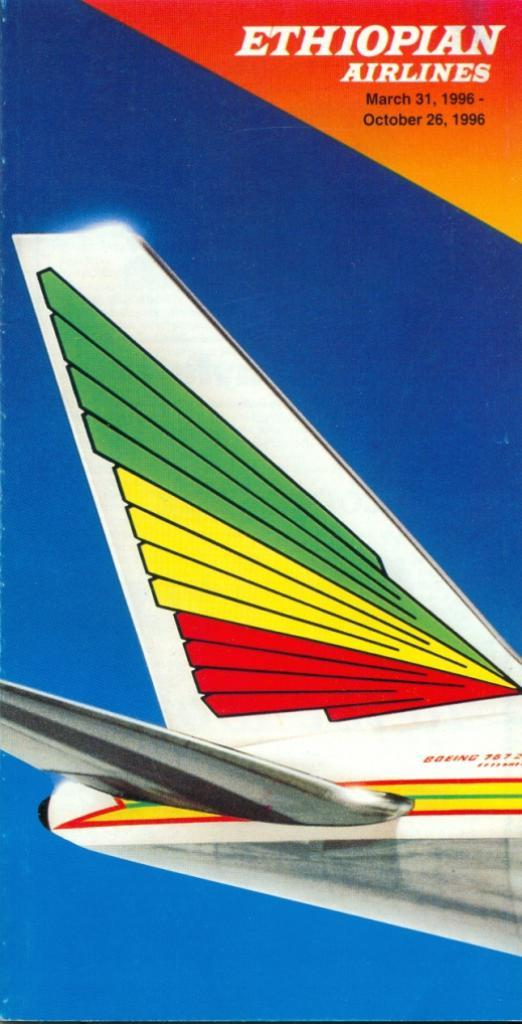What is the main subject of the image? The main subject of the image is a cover page. What color is the cover page? The cover page is in blue color. What is present at the top of the cover page? There is text on the top of the cover page. What image can be seen on the cover page? There is an airplane image on the cover page. How are the colors on the airplane image described? The airplane image has colorful paints on it. What type of agreement is being signed by the rabbit in the image? There is no rabbit present in the image, and therefore no agreement being signed. 